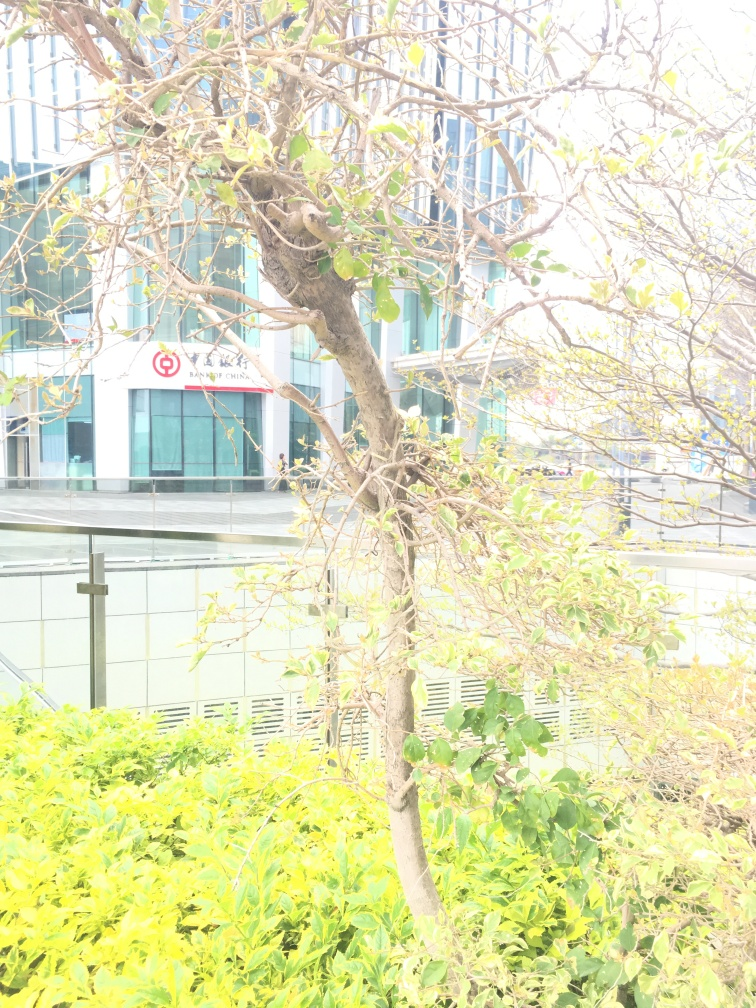What might be the cause of the overexposed appearance of this photograph? The overexposed appearance of the image can be attributed to several factors such as strong daylight possibly combined with camera settings that allowed too much light to enter the lens during the shot. Improper adjustment of the camera's exposure settings, like a high ISO, slow shutter speed, or wide aperture, could have contributed to this effect. How could this effect be prevented in future photographs? To prevent overexposure in future photographs, one should adjust the camera's settings to suit the lighting conditions. Lowering the ISO value, increasing the shutter speed, or narrowing the aperture could help balance the exposure. Additionally, using features like exposure compensation or shooting in RAW format to adjust the exposure in post-processing can be helpful strategies. 